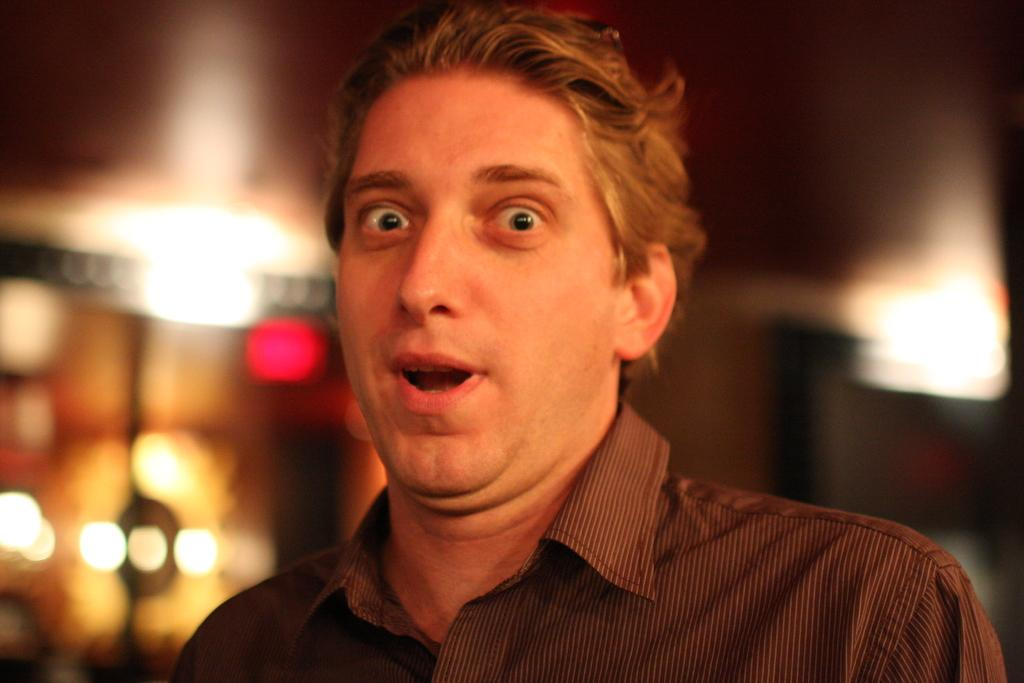What is the main subject of the image? There is a man standing in the middle of the image. What is the man's facial expression in the image? The man is smiling in the image. Can you describe the background of the image? The background of the image is blurred. What verse is the man reciting in the image? There is no indication in the image that the man is reciting a verse, so it cannot be determined from the picture. 